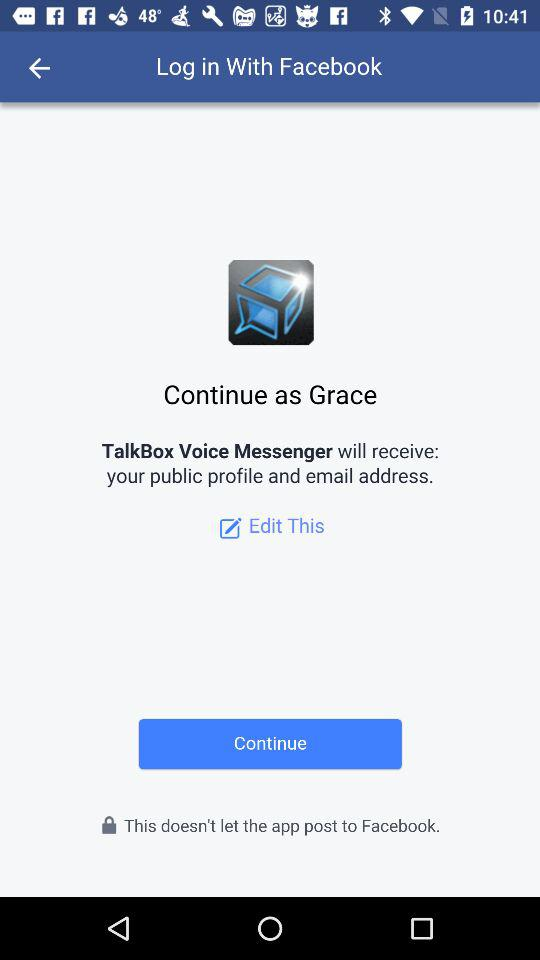What is the login name? The login name is Grace. 